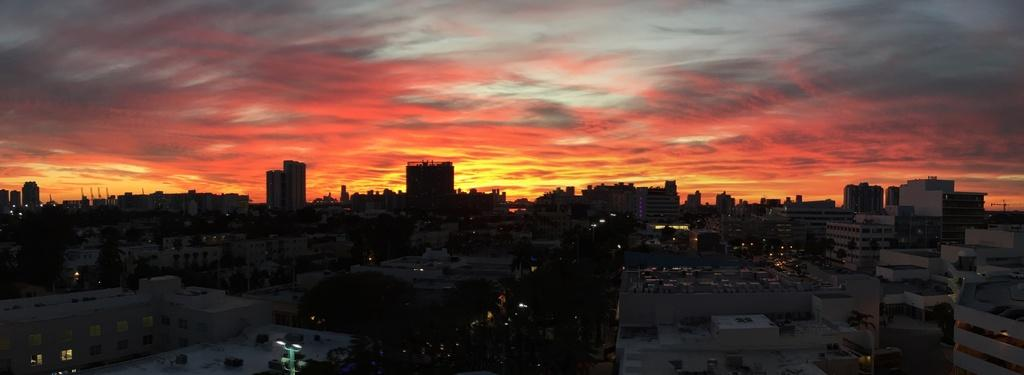What type of structures can be seen in the image? There are buildings in the image. What type of vegetation is present in the image? There are trees in the image. What type of vertical structures can be seen in the image? There are poles in the image. What type of illumination is present in the image? There are lights in the image. What is visible in the background of the image? The sky is visible in the background of the image. Can you see a needle being used in the image? There is no needle present in the image. How many people are walking in the image? There are no people visible in the image, so it is not possible to determine how many people might be walking. What type of watering equipment is present in the image? There is no hose or watering equipment present in the image. 